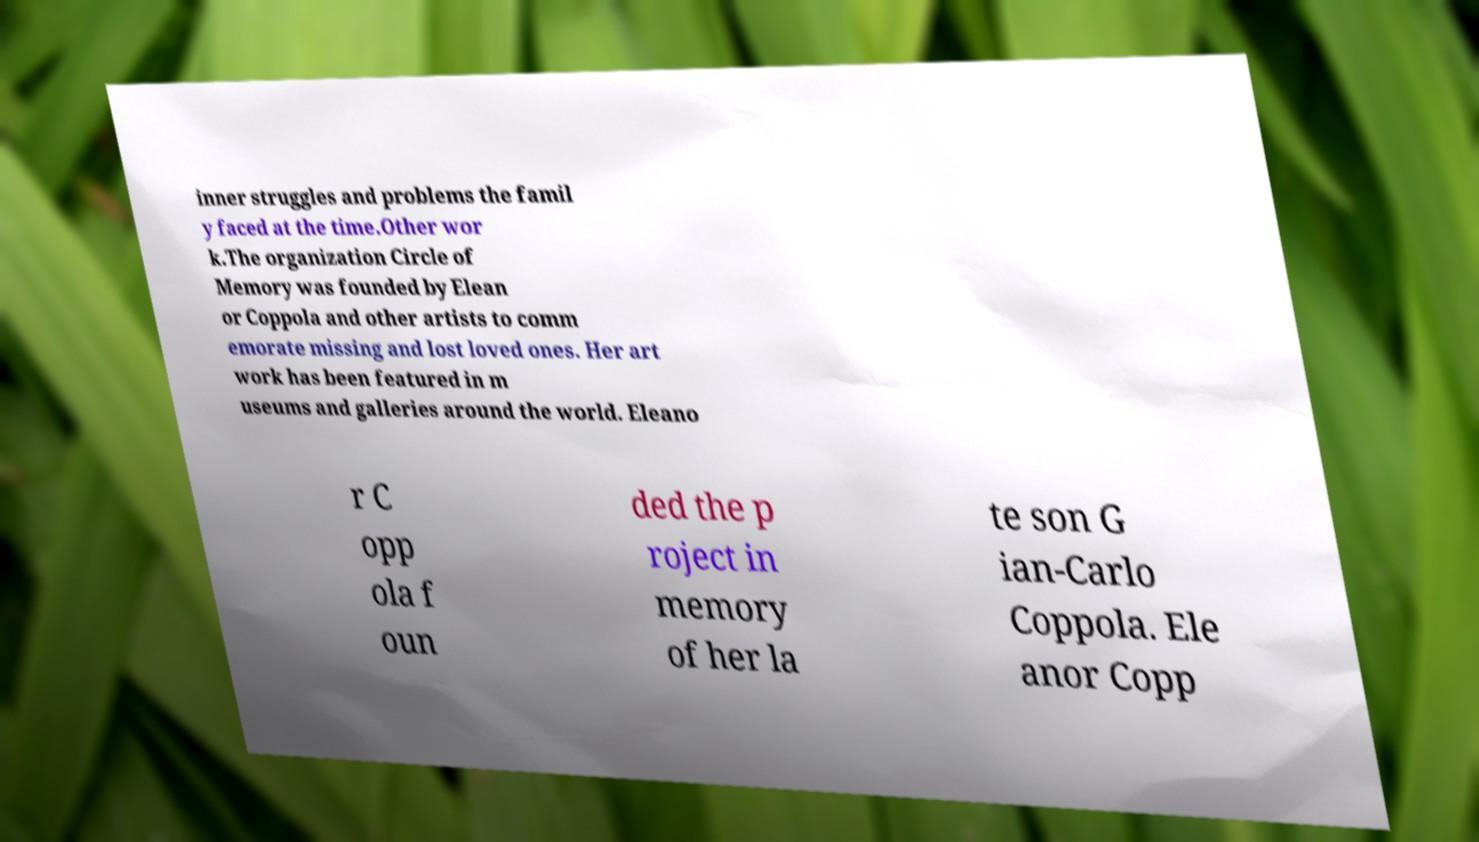I need the written content from this picture converted into text. Can you do that? inner struggles and problems the famil y faced at the time.Other wor k.The organization Circle of Memory was founded by Elean or Coppola and other artists to comm emorate missing and lost loved ones. Her art work has been featured in m useums and galleries around the world. Eleano r C opp ola f oun ded the p roject in memory of her la te son G ian-Carlo Coppola. Ele anor Copp 